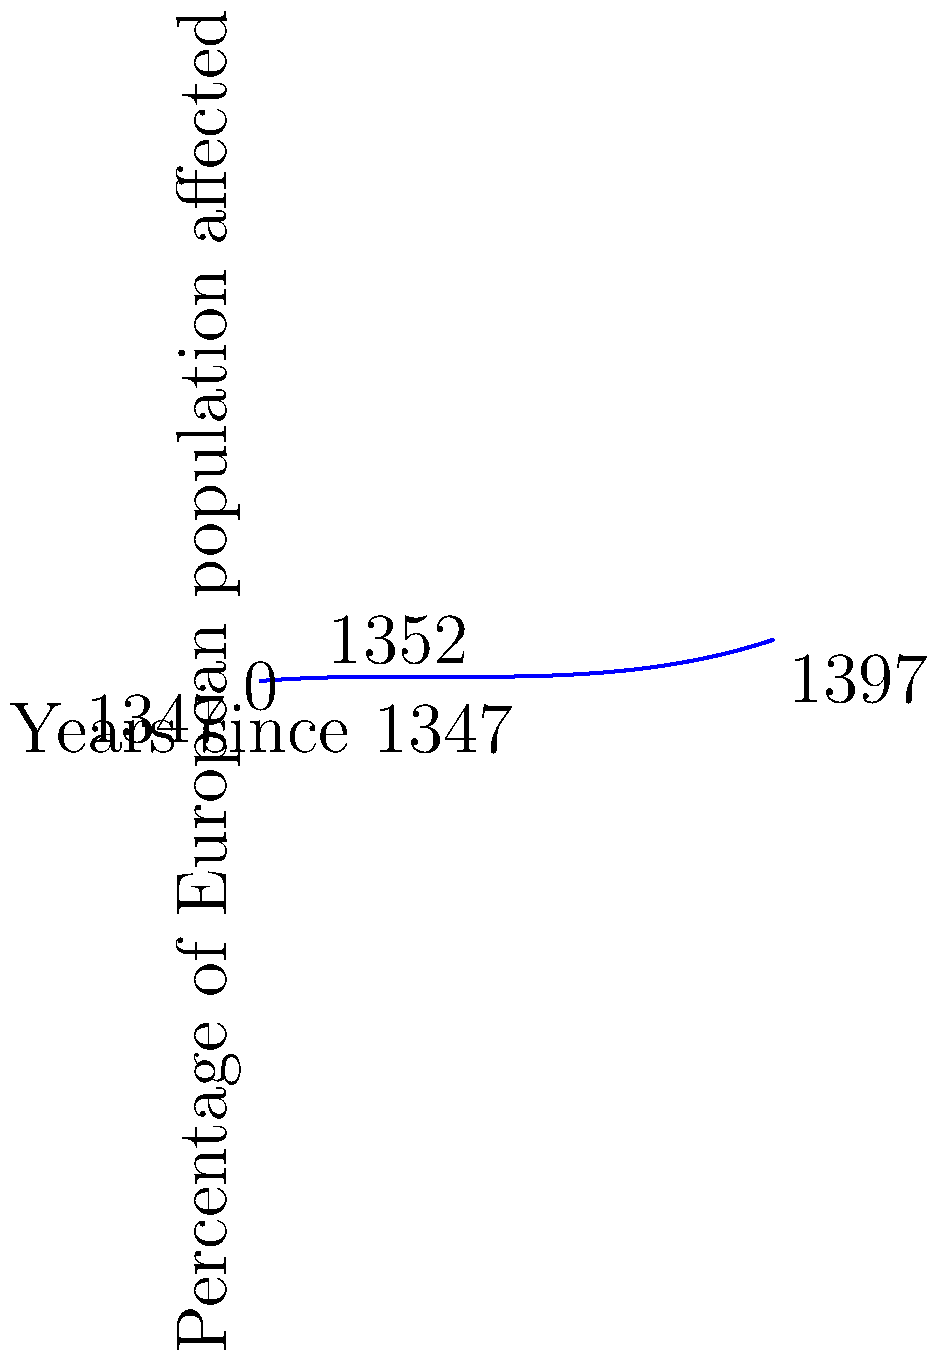The polynomial $f(x) = 0.0001x^3 - 0.005x^2 + 0.08x$ represents the spread of the Black Death across Europe, where $x$ is the number of years since 1347 and $f(x)$ is the percentage of the European population affected. Based on this model, in which year did the Black Death reach its peak in Europe, and what percentage of the population was affected at that time? To find the peak of the Black Death:

1) First, we need to find the derivative of $f(x)$:
   $f'(x) = 0.0003x^2 - 0.01x + 0.08$

2) Set $f'(x) = 0$ to find the critical points:
   $0.0003x^2 - 0.01x + 0.08 = 0$

3) Solve this quadratic equation:
   $x = \frac{0.01 \pm \sqrt{0.01^2 - 4(0.0003)(0.08)}}{2(0.0003)}$
   $x \approx 5$ or $x \approx 28.33$

4) The smaller value, $x \approx 5$, corresponds to the peak (maximum).

5) This means the peak occurred about 5 years after 1347, which is 1352.

6) To find the percentage affected at the peak, plug $x = 5$ into the original function:
   $f(5) = 0.0001(5^3) - 0.005(5^2) + 0.08(5) \approx 0.33125$

7) Convert to a percentage: $0.33125 * 100 \approx 33.13\%$

Therefore, the Black Death reached its peak in 1352, affecting approximately 33.13% of the European population.
Answer: 1352; 33.13% 